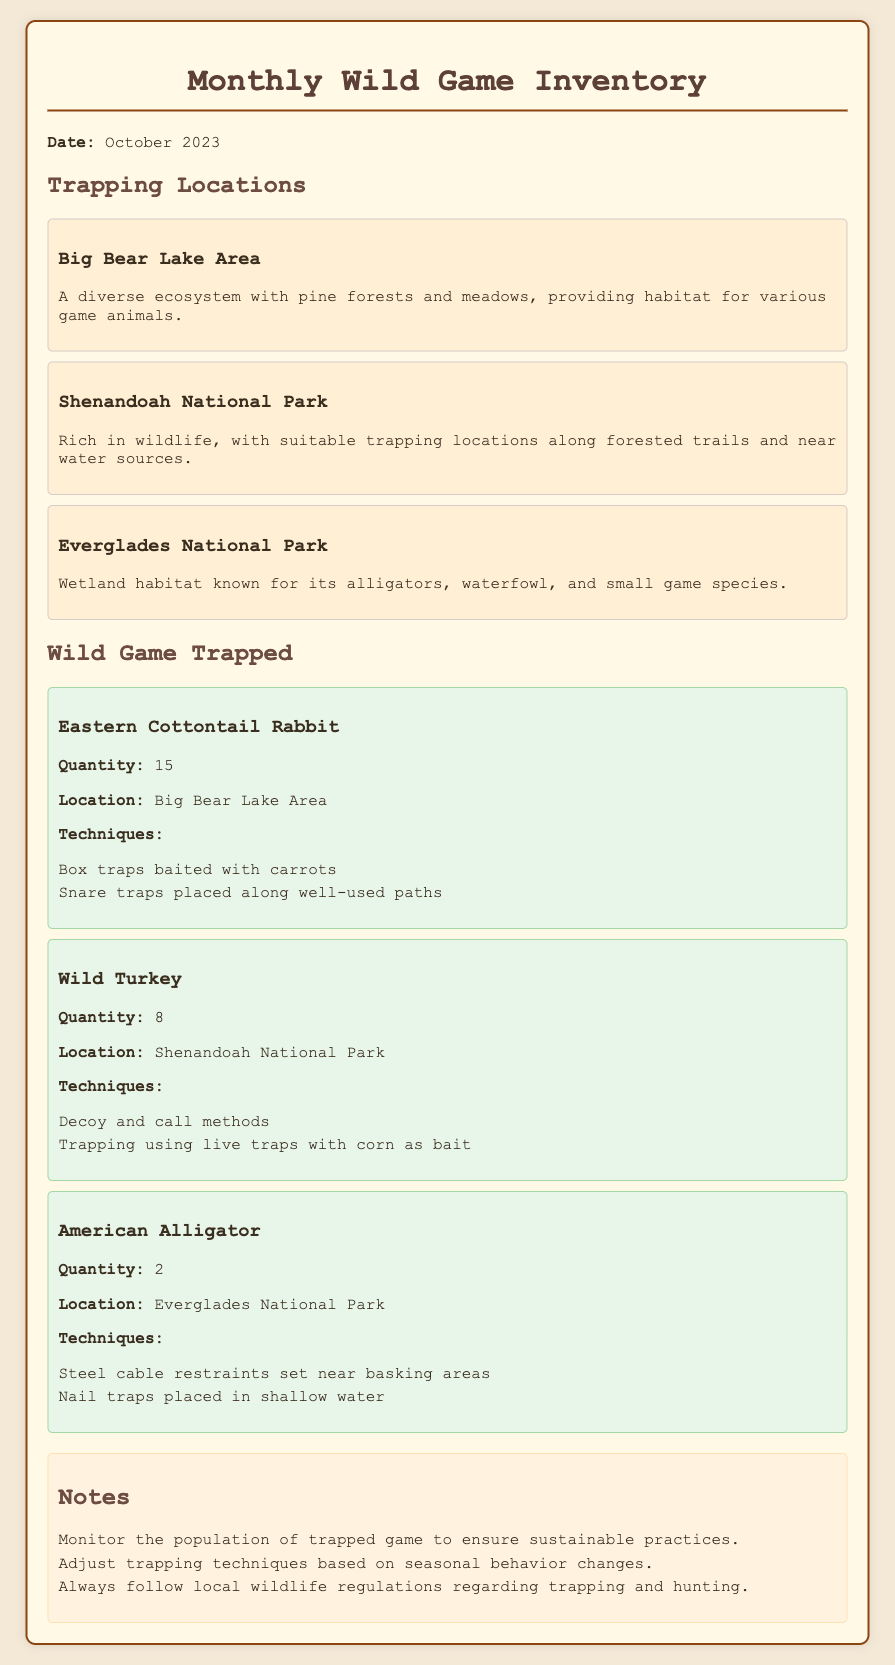What is the date of the inventory? The date of the inventory is stated in the document as October 2023.
Answer: October 2023 How many Eastern Cottontail Rabbits were trapped? The quantity of Eastern Cottontail Rabbits trapped is specified in the document as 15.
Answer: 15 Which area had Wild Turkey trapped? The area where Wild Turkey was trapped is mentioned as Shenandoah National Park.
Answer: Shenandoah National Park What trapping technique was used for the American Alligator? One of the techniques used for trapping American Alligators includes steel cable restraints set near basking areas, which is detailed in the document.
Answer: Steel cable restraints What is a recommendation made in the notes? One of the recommendations mentioned in the notes is to monitor the population of trapped game to ensure sustainable practices.
Answer: Monitor the population How many locations are listed for trapping? The document lists three locations for trapping.
Answer: 3 What is a technique for trapping Wild Turkey? The document mentions decoy and call methods as a technique for trapping Wild Turkey.
Answer: Decoy and call methods In which location is trapping best suited due to water sources? The location that is rich in wildlife with suitable trapping locations along water sources is Shenandoah National Park.
Answer: Shenandoah National Park 